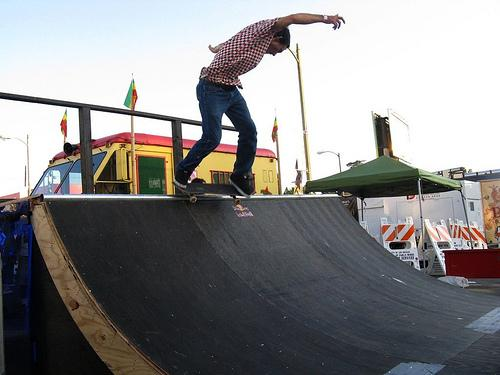Tell me about the person in the image and his clothes. The person is a skateboarder wearing a red plaid shirt, blue jeans and has a watch on his hand. Describe the skateboarding action that the person is performing in the image. The skateboarder is at the top of the ramp, jumping into the air with their skateboard under them. What type of vehicle is present in the image and what are its colors? A yellow food truck with a red top and flags is present in the image. Identify the main object in the image and its color. The main object is a large wooden skateboard ramp, which is black in color. 